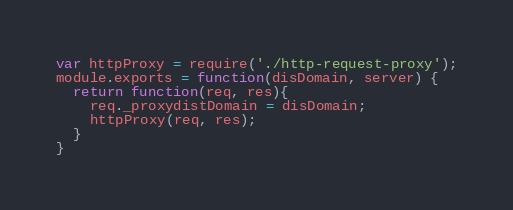Convert code to text. <code><loc_0><loc_0><loc_500><loc_500><_JavaScript_>var httpProxy = require('./http-request-proxy');
module.exports = function(disDomain, server) {
  return function(req, res){
    req._proxydistDomain = disDomain;
    httpProxy(req, res);
  }
}</code> 